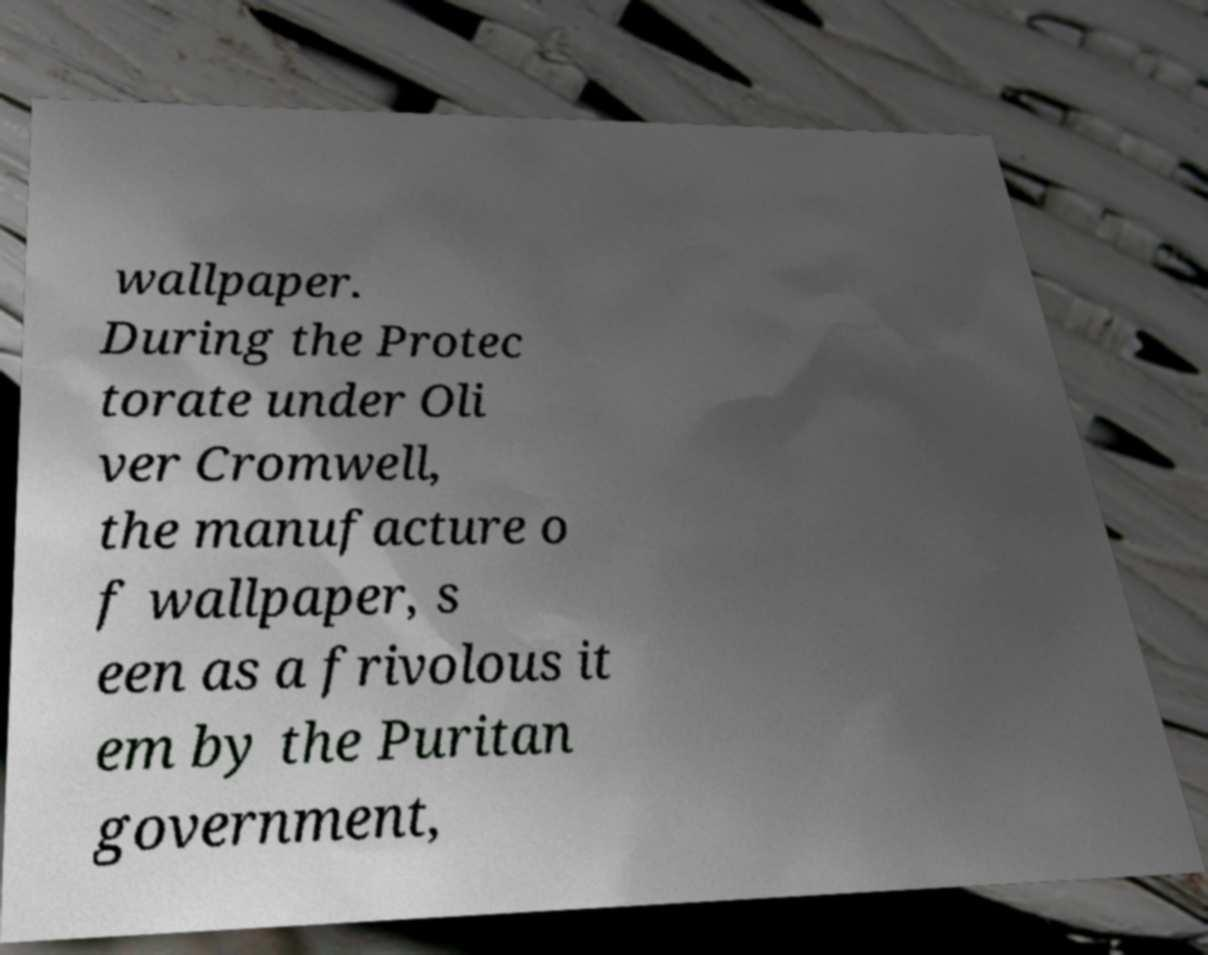What messages or text are displayed in this image? I need them in a readable, typed format. wallpaper. During the Protec torate under Oli ver Cromwell, the manufacture o f wallpaper, s een as a frivolous it em by the Puritan government, 